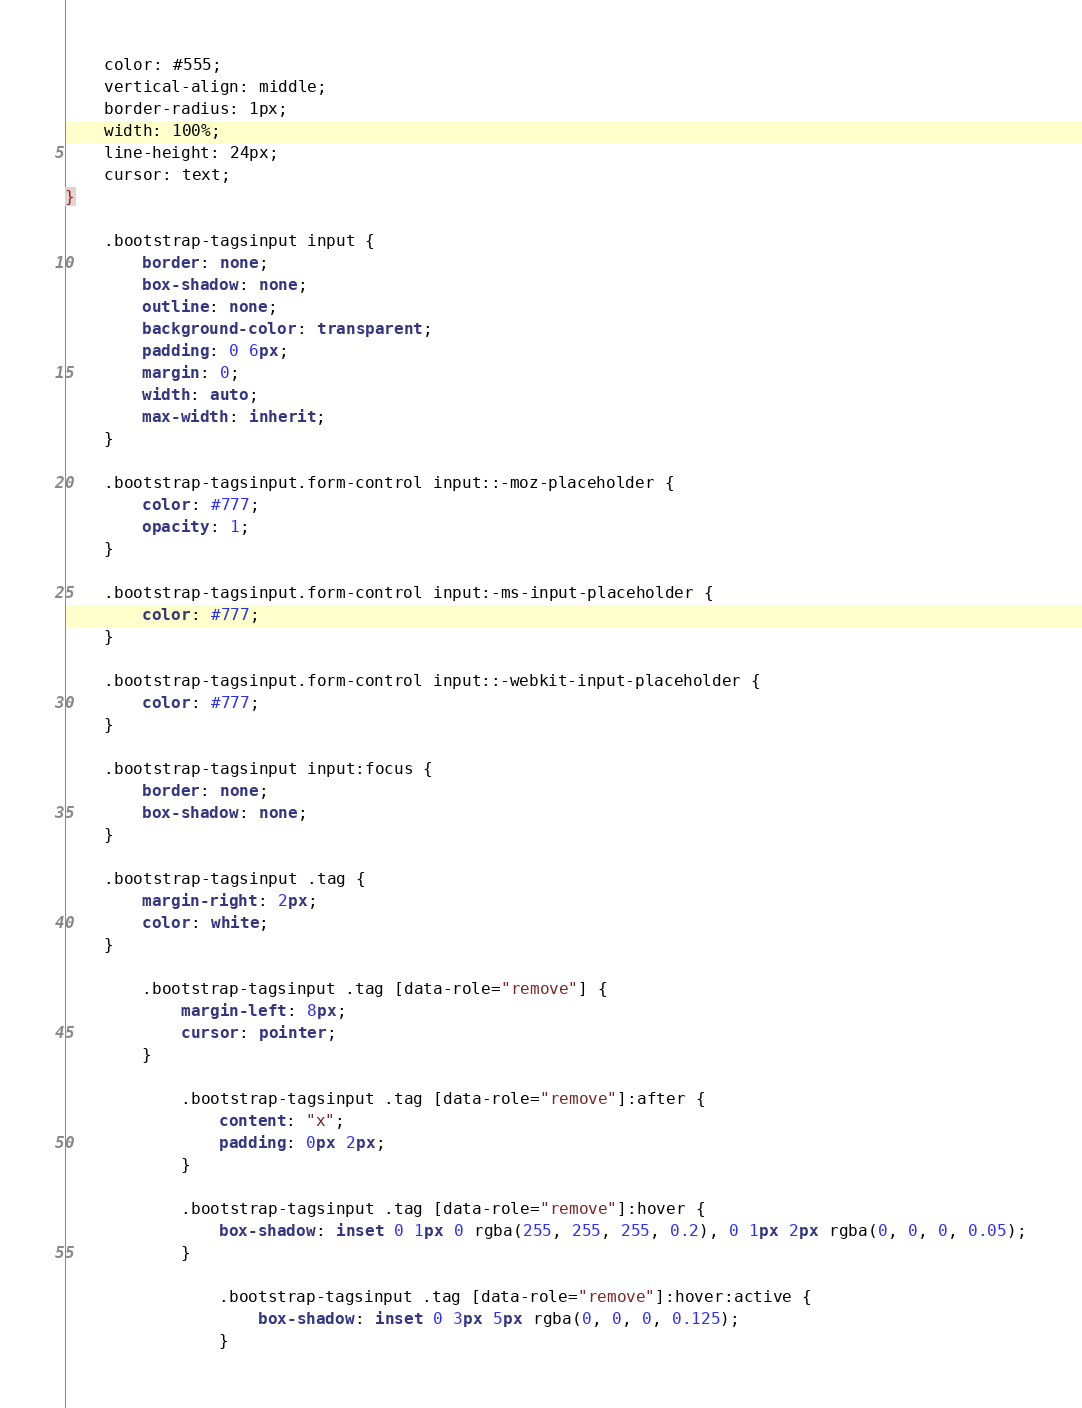<code> <loc_0><loc_0><loc_500><loc_500><_CSS_>    color: #555;
    vertical-align: middle;
    border-radius: 1px;
    width: 100%;
    line-height: 24px;
    cursor: text;
}

    .bootstrap-tagsinput input {
        border: none;
        box-shadow: none;
        outline: none;
        background-color: transparent;
        padding: 0 6px;
        margin: 0;
        width: auto;
        max-width: inherit;
    }

    .bootstrap-tagsinput.form-control input::-moz-placeholder {
        color: #777;
        opacity: 1;
    }

    .bootstrap-tagsinput.form-control input:-ms-input-placeholder {
        color: #777;
    }

    .bootstrap-tagsinput.form-control input::-webkit-input-placeholder {
        color: #777;
    }

    .bootstrap-tagsinput input:focus {
        border: none;
        box-shadow: none;
    }

    .bootstrap-tagsinput .tag {
        margin-right: 2px;
        color: white;
    }

        .bootstrap-tagsinput .tag [data-role="remove"] {
            margin-left: 8px;
            cursor: pointer;
        }

            .bootstrap-tagsinput .tag [data-role="remove"]:after {
                content: "x";
                padding: 0px 2px;
            }

            .bootstrap-tagsinput .tag [data-role="remove"]:hover {
                box-shadow: inset 0 1px 0 rgba(255, 255, 255, 0.2), 0 1px 2px rgba(0, 0, 0, 0.05);
            }

                .bootstrap-tagsinput .tag [data-role="remove"]:hover:active {
                    box-shadow: inset 0 3px 5px rgba(0, 0, 0, 0.125);
                }
</code> 